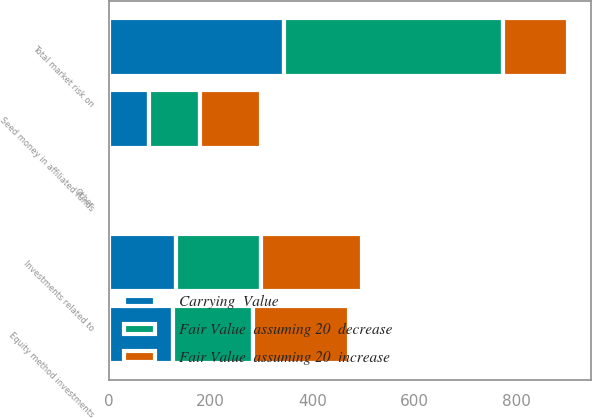Convert chart to OTSL. <chart><loc_0><loc_0><loc_500><loc_500><stacked_bar_chart><ecel><fcel>Investments related to<fcel>Seed money in affiliated funds<fcel>Equity method investments<fcel>Other<fcel>Total market risk on<nl><fcel>Fair Value  assuming 20  decrease<fcel>165.5<fcel>99.5<fcel>156.9<fcel>7.5<fcel>429.4<nl><fcel>Fair Value  assuming 20  increase<fcel>198.6<fcel>119.4<fcel>188.3<fcel>9<fcel>128.95<nl><fcel>Carrying  Value<fcel>132.4<fcel>79.6<fcel>125.5<fcel>6<fcel>343.5<nl></chart> 